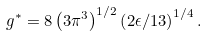<formula> <loc_0><loc_0><loc_500><loc_500>g ^ { \ast } = 8 \left ( 3 \pi ^ { 3 } \right ) ^ { 1 / 2 } \left ( 2 \epsilon / 1 3 \right ) ^ { 1 / 4 } .</formula> 